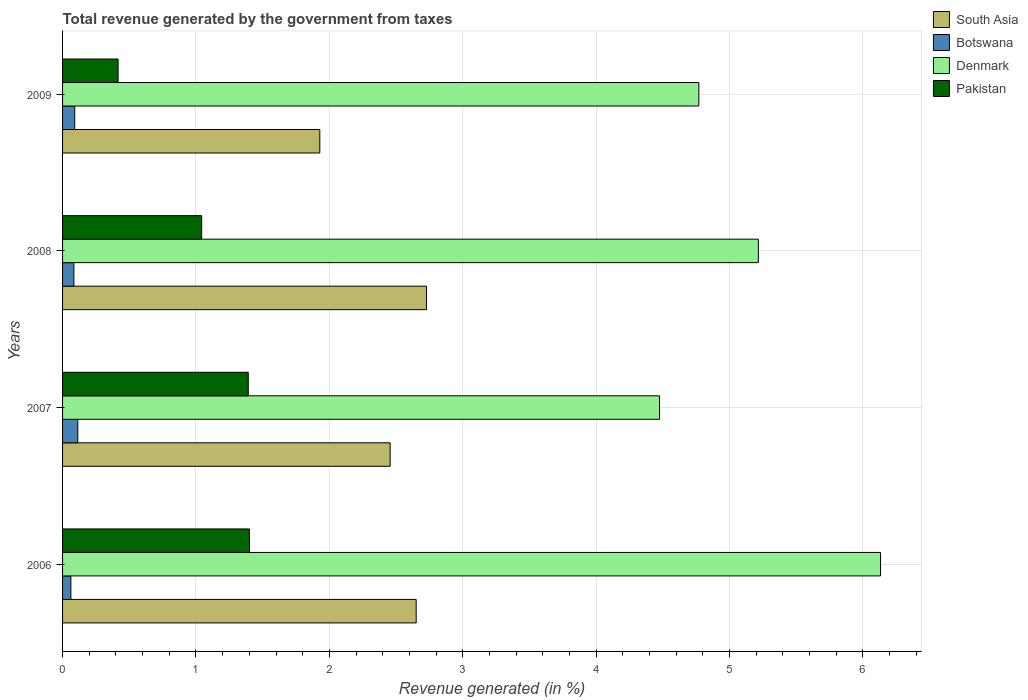How many different coloured bars are there?
Make the answer very short. 4. How many bars are there on the 2nd tick from the top?
Keep it short and to the point. 4. How many bars are there on the 2nd tick from the bottom?
Offer a terse response. 4. What is the label of the 1st group of bars from the top?
Your answer should be compact. 2009. In how many cases, is the number of bars for a given year not equal to the number of legend labels?
Your answer should be very brief. 0. What is the total revenue generated in Pakistan in 2007?
Make the answer very short. 1.39. Across all years, what is the maximum total revenue generated in Botswana?
Offer a very short reply. 0.11. Across all years, what is the minimum total revenue generated in Denmark?
Keep it short and to the point. 4.47. In which year was the total revenue generated in Denmark maximum?
Provide a succinct answer. 2006. In which year was the total revenue generated in South Asia minimum?
Give a very brief answer. 2009. What is the total total revenue generated in South Asia in the graph?
Keep it short and to the point. 9.76. What is the difference between the total revenue generated in South Asia in 2007 and that in 2009?
Provide a succinct answer. 0.53. What is the difference between the total revenue generated in Denmark in 2006 and the total revenue generated in South Asia in 2007?
Your response must be concise. 3.68. What is the average total revenue generated in Denmark per year?
Keep it short and to the point. 5.15. In the year 2008, what is the difference between the total revenue generated in Pakistan and total revenue generated in Denmark?
Provide a short and direct response. -4.17. What is the ratio of the total revenue generated in Botswana in 2006 to that in 2009?
Your answer should be compact. 0.68. Is the total revenue generated in South Asia in 2006 less than that in 2009?
Ensure brevity in your answer.  No. Is the difference between the total revenue generated in Pakistan in 2007 and 2009 greater than the difference between the total revenue generated in Denmark in 2007 and 2009?
Your response must be concise. Yes. What is the difference between the highest and the second highest total revenue generated in Pakistan?
Your answer should be compact. 0.01. What is the difference between the highest and the lowest total revenue generated in Botswana?
Make the answer very short. 0.05. Is the sum of the total revenue generated in Botswana in 2008 and 2009 greater than the maximum total revenue generated in Denmark across all years?
Offer a very short reply. No. Is it the case that in every year, the sum of the total revenue generated in Pakistan and total revenue generated in Botswana is greater than the sum of total revenue generated in Denmark and total revenue generated in South Asia?
Make the answer very short. No. What does the 3rd bar from the top in 2008 represents?
Your answer should be very brief. Botswana. What does the 2nd bar from the bottom in 2009 represents?
Your answer should be compact. Botswana. How many bars are there?
Give a very brief answer. 16. Are all the bars in the graph horizontal?
Keep it short and to the point. Yes. What is the difference between two consecutive major ticks on the X-axis?
Offer a very short reply. 1. Are the values on the major ticks of X-axis written in scientific E-notation?
Ensure brevity in your answer.  No. Where does the legend appear in the graph?
Provide a succinct answer. Top right. How are the legend labels stacked?
Ensure brevity in your answer.  Vertical. What is the title of the graph?
Your answer should be compact. Total revenue generated by the government from taxes. Does "Euro area" appear as one of the legend labels in the graph?
Keep it short and to the point. No. What is the label or title of the X-axis?
Give a very brief answer. Revenue generated (in %). What is the Revenue generated (in %) in South Asia in 2006?
Your response must be concise. 2.65. What is the Revenue generated (in %) in Botswana in 2006?
Your answer should be compact. 0.06. What is the Revenue generated (in %) of Denmark in 2006?
Make the answer very short. 6.13. What is the Revenue generated (in %) of Pakistan in 2006?
Give a very brief answer. 1.4. What is the Revenue generated (in %) in South Asia in 2007?
Offer a very short reply. 2.46. What is the Revenue generated (in %) in Botswana in 2007?
Your response must be concise. 0.11. What is the Revenue generated (in %) of Denmark in 2007?
Provide a short and direct response. 4.47. What is the Revenue generated (in %) of Pakistan in 2007?
Make the answer very short. 1.39. What is the Revenue generated (in %) of South Asia in 2008?
Provide a short and direct response. 2.73. What is the Revenue generated (in %) of Botswana in 2008?
Ensure brevity in your answer.  0.08. What is the Revenue generated (in %) of Denmark in 2008?
Keep it short and to the point. 5.22. What is the Revenue generated (in %) of Pakistan in 2008?
Give a very brief answer. 1.04. What is the Revenue generated (in %) in South Asia in 2009?
Provide a succinct answer. 1.93. What is the Revenue generated (in %) in Botswana in 2009?
Your answer should be compact. 0.09. What is the Revenue generated (in %) in Denmark in 2009?
Your answer should be very brief. 4.77. What is the Revenue generated (in %) in Pakistan in 2009?
Offer a terse response. 0.42. Across all years, what is the maximum Revenue generated (in %) in South Asia?
Provide a succinct answer. 2.73. Across all years, what is the maximum Revenue generated (in %) of Botswana?
Your answer should be compact. 0.11. Across all years, what is the maximum Revenue generated (in %) of Denmark?
Your answer should be very brief. 6.13. Across all years, what is the maximum Revenue generated (in %) in Pakistan?
Your response must be concise. 1.4. Across all years, what is the minimum Revenue generated (in %) in South Asia?
Make the answer very short. 1.93. Across all years, what is the minimum Revenue generated (in %) of Botswana?
Provide a succinct answer. 0.06. Across all years, what is the minimum Revenue generated (in %) in Denmark?
Offer a very short reply. 4.47. Across all years, what is the minimum Revenue generated (in %) in Pakistan?
Your answer should be compact. 0.42. What is the total Revenue generated (in %) of South Asia in the graph?
Give a very brief answer. 9.76. What is the total Revenue generated (in %) in Botswana in the graph?
Your response must be concise. 0.35. What is the total Revenue generated (in %) of Denmark in the graph?
Offer a very short reply. 20.59. What is the total Revenue generated (in %) of Pakistan in the graph?
Give a very brief answer. 4.25. What is the difference between the Revenue generated (in %) in South Asia in 2006 and that in 2007?
Keep it short and to the point. 0.2. What is the difference between the Revenue generated (in %) of Botswana in 2006 and that in 2007?
Your answer should be very brief. -0.05. What is the difference between the Revenue generated (in %) in Denmark in 2006 and that in 2007?
Ensure brevity in your answer.  1.66. What is the difference between the Revenue generated (in %) of Pakistan in 2006 and that in 2007?
Provide a short and direct response. 0.01. What is the difference between the Revenue generated (in %) in South Asia in 2006 and that in 2008?
Provide a short and direct response. -0.08. What is the difference between the Revenue generated (in %) in Botswana in 2006 and that in 2008?
Your response must be concise. -0.02. What is the difference between the Revenue generated (in %) in Denmark in 2006 and that in 2008?
Your answer should be compact. 0.92. What is the difference between the Revenue generated (in %) of Pakistan in 2006 and that in 2008?
Provide a succinct answer. 0.36. What is the difference between the Revenue generated (in %) of South Asia in 2006 and that in 2009?
Offer a terse response. 0.72. What is the difference between the Revenue generated (in %) of Botswana in 2006 and that in 2009?
Ensure brevity in your answer.  -0.03. What is the difference between the Revenue generated (in %) of Denmark in 2006 and that in 2009?
Make the answer very short. 1.36. What is the difference between the Revenue generated (in %) in South Asia in 2007 and that in 2008?
Offer a very short reply. -0.27. What is the difference between the Revenue generated (in %) of Botswana in 2007 and that in 2008?
Your answer should be compact. 0.03. What is the difference between the Revenue generated (in %) of Denmark in 2007 and that in 2008?
Provide a short and direct response. -0.74. What is the difference between the Revenue generated (in %) in Pakistan in 2007 and that in 2008?
Your answer should be very brief. 0.35. What is the difference between the Revenue generated (in %) of South Asia in 2007 and that in 2009?
Make the answer very short. 0.53. What is the difference between the Revenue generated (in %) in Botswana in 2007 and that in 2009?
Offer a very short reply. 0.02. What is the difference between the Revenue generated (in %) in Denmark in 2007 and that in 2009?
Offer a terse response. -0.29. What is the difference between the Revenue generated (in %) of Pakistan in 2007 and that in 2009?
Provide a short and direct response. 0.98. What is the difference between the Revenue generated (in %) of South Asia in 2008 and that in 2009?
Your answer should be very brief. 0.8. What is the difference between the Revenue generated (in %) of Botswana in 2008 and that in 2009?
Provide a short and direct response. -0.01. What is the difference between the Revenue generated (in %) in Denmark in 2008 and that in 2009?
Your answer should be very brief. 0.45. What is the difference between the Revenue generated (in %) of Pakistan in 2008 and that in 2009?
Your answer should be very brief. 0.63. What is the difference between the Revenue generated (in %) in South Asia in 2006 and the Revenue generated (in %) in Botswana in 2007?
Keep it short and to the point. 2.54. What is the difference between the Revenue generated (in %) of South Asia in 2006 and the Revenue generated (in %) of Denmark in 2007?
Make the answer very short. -1.82. What is the difference between the Revenue generated (in %) of South Asia in 2006 and the Revenue generated (in %) of Pakistan in 2007?
Provide a succinct answer. 1.26. What is the difference between the Revenue generated (in %) in Botswana in 2006 and the Revenue generated (in %) in Denmark in 2007?
Offer a very short reply. -4.41. What is the difference between the Revenue generated (in %) in Botswana in 2006 and the Revenue generated (in %) in Pakistan in 2007?
Give a very brief answer. -1.33. What is the difference between the Revenue generated (in %) of Denmark in 2006 and the Revenue generated (in %) of Pakistan in 2007?
Provide a succinct answer. 4.74. What is the difference between the Revenue generated (in %) of South Asia in 2006 and the Revenue generated (in %) of Botswana in 2008?
Your answer should be compact. 2.57. What is the difference between the Revenue generated (in %) in South Asia in 2006 and the Revenue generated (in %) in Denmark in 2008?
Make the answer very short. -2.56. What is the difference between the Revenue generated (in %) of South Asia in 2006 and the Revenue generated (in %) of Pakistan in 2008?
Your response must be concise. 1.61. What is the difference between the Revenue generated (in %) of Botswana in 2006 and the Revenue generated (in %) of Denmark in 2008?
Ensure brevity in your answer.  -5.15. What is the difference between the Revenue generated (in %) of Botswana in 2006 and the Revenue generated (in %) of Pakistan in 2008?
Provide a succinct answer. -0.98. What is the difference between the Revenue generated (in %) in Denmark in 2006 and the Revenue generated (in %) in Pakistan in 2008?
Give a very brief answer. 5.09. What is the difference between the Revenue generated (in %) in South Asia in 2006 and the Revenue generated (in %) in Botswana in 2009?
Your answer should be compact. 2.56. What is the difference between the Revenue generated (in %) in South Asia in 2006 and the Revenue generated (in %) in Denmark in 2009?
Make the answer very short. -2.12. What is the difference between the Revenue generated (in %) in South Asia in 2006 and the Revenue generated (in %) in Pakistan in 2009?
Provide a succinct answer. 2.23. What is the difference between the Revenue generated (in %) in Botswana in 2006 and the Revenue generated (in %) in Denmark in 2009?
Provide a succinct answer. -4.71. What is the difference between the Revenue generated (in %) in Botswana in 2006 and the Revenue generated (in %) in Pakistan in 2009?
Your response must be concise. -0.35. What is the difference between the Revenue generated (in %) of Denmark in 2006 and the Revenue generated (in %) of Pakistan in 2009?
Offer a terse response. 5.72. What is the difference between the Revenue generated (in %) in South Asia in 2007 and the Revenue generated (in %) in Botswana in 2008?
Your response must be concise. 2.37. What is the difference between the Revenue generated (in %) of South Asia in 2007 and the Revenue generated (in %) of Denmark in 2008?
Provide a succinct answer. -2.76. What is the difference between the Revenue generated (in %) in South Asia in 2007 and the Revenue generated (in %) in Pakistan in 2008?
Your answer should be very brief. 1.41. What is the difference between the Revenue generated (in %) in Botswana in 2007 and the Revenue generated (in %) in Denmark in 2008?
Offer a very short reply. -5.1. What is the difference between the Revenue generated (in %) of Botswana in 2007 and the Revenue generated (in %) of Pakistan in 2008?
Give a very brief answer. -0.93. What is the difference between the Revenue generated (in %) of Denmark in 2007 and the Revenue generated (in %) of Pakistan in 2008?
Give a very brief answer. 3.43. What is the difference between the Revenue generated (in %) in South Asia in 2007 and the Revenue generated (in %) in Botswana in 2009?
Offer a very short reply. 2.36. What is the difference between the Revenue generated (in %) in South Asia in 2007 and the Revenue generated (in %) in Denmark in 2009?
Provide a short and direct response. -2.31. What is the difference between the Revenue generated (in %) in South Asia in 2007 and the Revenue generated (in %) in Pakistan in 2009?
Ensure brevity in your answer.  2.04. What is the difference between the Revenue generated (in %) in Botswana in 2007 and the Revenue generated (in %) in Denmark in 2009?
Give a very brief answer. -4.66. What is the difference between the Revenue generated (in %) of Botswana in 2007 and the Revenue generated (in %) of Pakistan in 2009?
Make the answer very short. -0.3. What is the difference between the Revenue generated (in %) in Denmark in 2007 and the Revenue generated (in %) in Pakistan in 2009?
Your answer should be very brief. 4.06. What is the difference between the Revenue generated (in %) in South Asia in 2008 and the Revenue generated (in %) in Botswana in 2009?
Your answer should be compact. 2.64. What is the difference between the Revenue generated (in %) in South Asia in 2008 and the Revenue generated (in %) in Denmark in 2009?
Your answer should be very brief. -2.04. What is the difference between the Revenue generated (in %) of South Asia in 2008 and the Revenue generated (in %) of Pakistan in 2009?
Make the answer very short. 2.31. What is the difference between the Revenue generated (in %) in Botswana in 2008 and the Revenue generated (in %) in Denmark in 2009?
Give a very brief answer. -4.68. What is the difference between the Revenue generated (in %) of Botswana in 2008 and the Revenue generated (in %) of Pakistan in 2009?
Provide a succinct answer. -0.33. What is the difference between the Revenue generated (in %) in Denmark in 2008 and the Revenue generated (in %) in Pakistan in 2009?
Your response must be concise. 4.8. What is the average Revenue generated (in %) of South Asia per year?
Provide a short and direct response. 2.44. What is the average Revenue generated (in %) of Botswana per year?
Give a very brief answer. 0.09. What is the average Revenue generated (in %) in Denmark per year?
Keep it short and to the point. 5.15. What is the average Revenue generated (in %) in Pakistan per year?
Your answer should be very brief. 1.06. In the year 2006, what is the difference between the Revenue generated (in %) of South Asia and Revenue generated (in %) of Botswana?
Offer a very short reply. 2.59. In the year 2006, what is the difference between the Revenue generated (in %) of South Asia and Revenue generated (in %) of Denmark?
Give a very brief answer. -3.48. In the year 2006, what is the difference between the Revenue generated (in %) of South Asia and Revenue generated (in %) of Pakistan?
Your answer should be compact. 1.25. In the year 2006, what is the difference between the Revenue generated (in %) of Botswana and Revenue generated (in %) of Denmark?
Offer a very short reply. -6.07. In the year 2006, what is the difference between the Revenue generated (in %) in Botswana and Revenue generated (in %) in Pakistan?
Offer a terse response. -1.34. In the year 2006, what is the difference between the Revenue generated (in %) in Denmark and Revenue generated (in %) in Pakistan?
Offer a terse response. 4.73. In the year 2007, what is the difference between the Revenue generated (in %) in South Asia and Revenue generated (in %) in Botswana?
Your response must be concise. 2.34. In the year 2007, what is the difference between the Revenue generated (in %) in South Asia and Revenue generated (in %) in Denmark?
Offer a very short reply. -2.02. In the year 2007, what is the difference between the Revenue generated (in %) of South Asia and Revenue generated (in %) of Pakistan?
Keep it short and to the point. 1.06. In the year 2007, what is the difference between the Revenue generated (in %) in Botswana and Revenue generated (in %) in Denmark?
Keep it short and to the point. -4.36. In the year 2007, what is the difference between the Revenue generated (in %) in Botswana and Revenue generated (in %) in Pakistan?
Ensure brevity in your answer.  -1.28. In the year 2007, what is the difference between the Revenue generated (in %) in Denmark and Revenue generated (in %) in Pakistan?
Give a very brief answer. 3.08. In the year 2008, what is the difference between the Revenue generated (in %) in South Asia and Revenue generated (in %) in Botswana?
Offer a terse response. 2.64. In the year 2008, what is the difference between the Revenue generated (in %) in South Asia and Revenue generated (in %) in Denmark?
Keep it short and to the point. -2.49. In the year 2008, what is the difference between the Revenue generated (in %) of South Asia and Revenue generated (in %) of Pakistan?
Provide a succinct answer. 1.69. In the year 2008, what is the difference between the Revenue generated (in %) of Botswana and Revenue generated (in %) of Denmark?
Offer a terse response. -5.13. In the year 2008, what is the difference between the Revenue generated (in %) in Botswana and Revenue generated (in %) in Pakistan?
Your answer should be compact. -0.96. In the year 2008, what is the difference between the Revenue generated (in %) in Denmark and Revenue generated (in %) in Pakistan?
Provide a succinct answer. 4.17. In the year 2009, what is the difference between the Revenue generated (in %) in South Asia and Revenue generated (in %) in Botswana?
Offer a very short reply. 1.84. In the year 2009, what is the difference between the Revenue generated (in %) in South Asia and Revenue generated (in %) in Denmark?
Provide a short and direct response. -2.84. In the year 2009, what is the difference between the Revenue generated (in %) in South Asia and Revenue generated (in %) in Pakistan?
Keep it short and to the point. 1.51. In the year 2009, what is the difference between the Revenue generated (in %) in Botswana and Revenue generated (in %) in Denmark?
Your answer should be compact. -4.68. In the year 2009, what is the difference between the Revenue generated (in %) of Botswana and Revenue generated (in %) of Pakistan?
Your answer should be compact. -0.32. In the year 2009, what is the difference between the Revenue generated (in %) of Denmark and Revenue generated (in %) of Pakistan?
Provide a succinct answer. 4.35. What is the ratio of the Revenue generated (in %) in South Asia in 2006 to that in 2007?
Your response must be concise. 1.08. What is the ratio of the Revenue generated (in %) in Botswana in 2006 to that in 2007?
Offer a terse response. 0.55. What is the ratio of the Revenue generated (in %) of Denmark in 2006 to that in 2007?
Your response must be concise. 1.37. What is the ratio of the Revenue generated (in %) of Pakistan in 2006 to that in 2007?
Provide a short and direct response. 1.01. What is the ratio of the Revenue generated (in %) of South Asia in 2006 to that in 2008?
Your answer should be compact. 0.97. What is the ratio of the Revenue generated (in %) of Botswana in 2006 to that in 2008?
Offer a terse response. 0.74. What is the ratio of the Revenue generated (in %) of Denmark in 2006 to that in 2008?
Your response must be concise. 1.18. What is the ratio of the Revenue generated (in %) in Pakistan in 2006 to that in 2008?
Your answer should be compact. 1.34. What is the ratio of the Revenue generated (in %) in South Asia in 2006 to that in 2009?
Provide a succinct answer. 1.37. What is the ratio of the Revenue generated (in %) of Botswana in 2006 to that in 2009?
Make the answer very short. 0.68. What is the ratio of the Revenue generated (in %) of Denmark in 2006 to that in 2009?
Offer a very short reply. 1.29. What is the ratio of the Revenue generated (in %) of Pakistan in 2006 to that in 2009?
Your response must be concise. 3.37. What is the ratio of the Revenue generated (in %) in South Asia in 2007 to that in 2008?
Your response must be concise. 0.9. What is the ratio of the Revenue generated (in %) in Botswana in 2007 to that in 2008?
Your answer should be compact. 1.35. What is the ratio of the Revenue generated (in %) of Denmark in 2007 to that in 2008?
Your answer should be compact. 0.86. What is the ratio of the Revenue generated (in %) of Pakistan in 2007 to that in 2008?
Ensure brevity in your answer.  1.33. What is the ratio of the Revenue generated (in %) in South Asia in 2007 to that in 2009?
Give a very brief answer. 1.27. What is the ratio of the Revenue generated (in %) in Botswana in 2007 to that in 2009?
Provide a succinct answer. 1.25. What is the ratio of the Revenue generated (in %) of Denmark in 2007 to that in 2009?
Offer a terse response. 0.94. What is the ratio of the Revenue generated (in %) of Pakistan in 2007 to that in 2009?
Offer a terse response. 3.35. What is the ratio of the Revenue generated (in %) of South Asia in 2008 to that in 2009?
Keep it short and to the point. 1.41. What is the ratio of the Revenue generated (in %) in Botswana in 2008 to that in 2009?
Your answer should be very brief. 0.93. What is the ratio of the Revenue generated (in %) in Denmark in 2008 to that in 2009?
Your answer should be very brief. 1.09. What is the ratio of the Revenue generated (in %) in Pakistan in 2008 to that in 2009?
Offer a terse response. 2.51. What is the difference between the highest and the second highest Revenue generated (in %) of South Asia?
Give a very brief answer. 0.08. What is the difference between the highest and the second highest Revenue generated (in %) in Botswana?
Offer a very short reply. 0.02. What is the difference between the highest and the second highest Revenue generated (in %) of Denmark?
Ensure brevity in your answer.  0.92. What is the difference between the highest and the second highest Revenue generated (in %) in Pakistan?
Give a very brief answer. 0.01. What is the difference between the highest and the lowest Revenue generated (in %) of South Asia?
Offer a terse response. 0.8. What is the difference between the highest and the lowest Revenue generated (in %) in Botswana?
Your answer should be compact. 0.05. What is the difference between the highest and the lowest Revenue generated (in %) in Denmark?
Keep it short and to the point. 1.66. What is the difference between the highest and the lowest Revenue generated (in %) of Pakistan?
Keep it short and to the point. 0.98. 